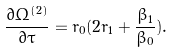<formula> <loc_0><loc_0><loc_500><loc_500>\frac { \partial \Omega ^ { ( 2 ) } } { \partial \tau } = r _ { 0 } ( 2 r _ { 1 } + \frac { \beta _ { 1 } } { \beta _ { 0 } } ) .</formula> 